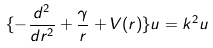Convert formula to latex. <formula><loc_0><loc_0><loc_500><loc_500>\{ - \frac { d ^ { 2 } } { d r ^ { 2 } } + \frac { \gamma } { r } + V ( r ) \} u = k ^ { 2 } u</formula> 